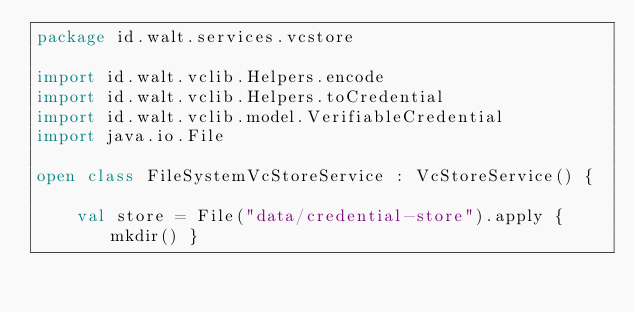<code> <loc_0><loc_0><loc_500><loc_500><_Kotlin_>package id.walt.services.vcstore

import id.walt.vclib.Helpers.encode
import id.walt.vclib.Helpers.toCredential
import id.walt.vclib.model.VerifiableCredential
import java.io.File

open class FileSystemVcStoreService : VcStoreService() {

    val store = File("data/credential-store").apply { mkdir() }
</code> 